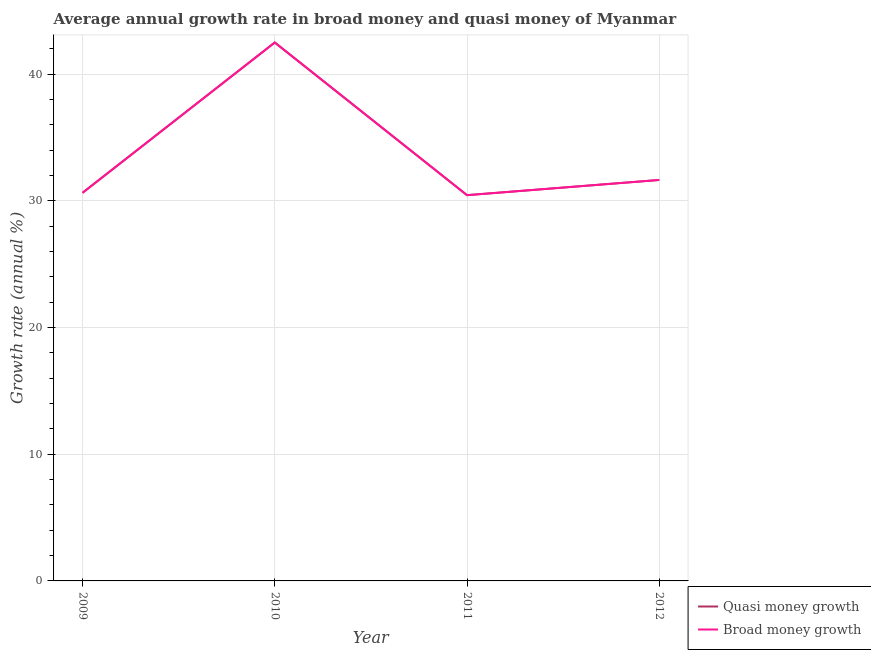Does the line corresponding to annual growth rate in quasi money intersect with the line corresponding to annual growth rate in broad money?
Make the answer very short. Yes. What is the annual growth rate in quasi money in 2009?
Provide a short and direct response. 30.64. Across all years, what is the maximum annual growth rate in broad money?
Ensure brevity in your answer.  42.5. Across all years, what is the minimum annual growth rate in quasi money?
Offer a terse response. 30.45. In which year was the annual growth rate in broad money minimum?
Make the answer very short. 2011. What is the total annual growth rate in broad money in the graph?
Provide a short and direct response. 135.24. What is the difference between the annual growth rate in quasi money in 2010 and that in 2012?
Provide a short and direct response. 10.85. What is the difference between the annual growth rate in quasi money in 2010 and the annual growth rate in broad money in 2011?
Provide a succinct answer. 12.05. What is the average annual growth rate in broad money per year?
Ensure brevity in your answer.  33.81. In how many years, is the annual growth rate in broad money greater than 4 %?
Make the answer very short. 4. What is the ratio of the annual growth rate in broad money in 2009 to that in 2012?
Make the answer very short. 0.97. Is the annual growth rate in broad money in 2010 less than that in 2012?
Provide a short and direct response. No. What is the difference between the highest and the second highest annual growth rate in quasi money?
Your answer should be compact. 10.85. What is the difference between the highest and the lowest annual growth rate in quasi money?
Ensure brevity in your answer.  12.05. In how many years, is the annual growth rate in broad money greater than the average annual growth rate in broad money taken over all years?
Make the answer very short. 1. Does the annual growth rate in quasi money monotonically increase over the years?
Your response must be concise. No. What is the difference between two consecutive major ticks on the Y-axis?
Your answer should be compact. 10. Does the graph contain any zero values?
Provide a succinct answer. No. Where does the legend appear in the graph?
Give a very brief answer. Bottom right. How many legend labels are there?
Offer a terse response. 2. How are the legend labels stacked?
Provide a short and direct response. Vertical. What is the title of the graph?
Keep it short and to the point. Average annual growth rate in broad money and quasi money of Myanmar. What is the label or title of the X-axis?
Offer a terse response. Year. What is the label or title of the Y-axis?
Offer a very short reply. Growth rate (annual %). What is the Growth rate (annual %) of Quasi money growth in 2009?
Offer a terse response. 30.64. What is the Growth rate (annual %) in Broad money growth in 2009?
Your answer should be compact. 30.64. What is the Growth rate (annual %) of Quasi money growth in 2010?
Provide a short and direct response. 42.5. What is the Growth rate (annual %) in Broad money growth in 2010?
Offer a terse response. 42.5. What is the Growth rate (annual %) in Quasi money growth in 2011?
Provide a succinct answer. 30.45. What is the Growth rate (annual %) of Broad money growth in 2011?
Give a very brief answer. 30.45. What is the Growth rate (annual %) of Quasi money growth in 2012?
Keep it short and to the point. 31.65. What is the Growth rate (annual %) of Broad money growth in 2012?
Your answer should be compact. 31.65. Across all years, what is the maximum Growth rate (annual %) of Quasi money growth?
Give a very brief answer. 42.5. Across all years, what is the maximum Growth rate (annual %) of Broad money growth?
Provide a short and direct response. 42.5. Across all years, what is the minimum Growth rate (annual %) of Quasi money growth?
Provide a short and direct response. 30.45. Across all years, what is the minimum Growth rate (annual %) in Broad money growth?
Provide a short and direct response. 30.45. What is the total Growth rate (annual %) in Quasi money growth in the graph?
Provide a short and direct response. 135.24. What is the total Growth rate (annual %) in Broad money growth in the graph?
Your response must be concise. 135.24. What is the difference between the Growth rate (annual %) in Quasi money growth in 2009 and that in 2010?
Ensure brevity in your answer.  -11.86. What is the difference between the Growth rate (annual %) of Broad money growth in 2009 and that in 2010?
Your answer should be very brief. -11.86. What is the difference between the Growth rate (annual %) in Quasi money growth in 2009 and that in 2011?
Keep it short and to the point. 0.19. What is the difference between the Growth rate (annual %) in Broad money growth in 2009 and that in 2011?
Keep it short and to the point. 0.19. What is the difference between the Growth rate (annual %) in Quasi money growth in 2009 and that in 2012?
Your answer should be compact. -1.01. What is the difference between the Growth rate (annual %) of Broad money growth in 2009 and that in 2012?
Offer a very short reply. -1.01. What is the difference between the Growth rate (annual %) of Quasi money growth in 2010 and that in 2011?
Your answer should be very brief. 12.05. What is the difference between the Growth rate (annual %) of Broad money growth in 2010 and that in 2011?
Provide a short and direct response. 12.05. What is the difference between the Growth rate (annual %) in Quasi money growth in 2010 and that in 2012?
Offer a terse response. 10.85. What is the difference between the Growth rate (annual %) in Broad money growth in 2010 and that in 2012?
Offer a terse response. 10.85. What is the difference between the Growth rate (annual %) of Quasi money growth in 2011 and that in 2012?
Provide a succinct answer. -1.2. What is the difference between the Growth rate (annual %) in Broad money growth in 2011 and that in 2012?
Keep it short and to the point. -1.2. What is the difference between the Growth rate (annual %) in Quasi money growth in 2009 and the Growth rate (annual %) in Broad money growth in 2010?
Keep it short and to the point. -11.86. What is the difference between the Growth rate (annual %) in Quasi money growth in 2009 and the Growth rate (annual %) in Broad money growth in 2011?
Your response must be concise. 0.19. What is the difference between the Growth rate (annual %) of Quasi money growth in 2009 and the Growth rate (annual %) of Broad money growth in 2012?
Give a very brief answer. -1.01. What is the difference between the Growth rate (annual %) of Quasi money growth in 2010 and the Growth rate (annual %) of Broad money growth in 2011?
Offer a terse response. 12.05. What is the difference between the Growth rate (annual %) in Quasi money growth in 2010 and the Growth rate (annual %) in Broad money growth in 2012?
Offer a terse response. 10.85. What is the difference between the Growth rate (annual %) of Quasi money growth in 2011 and the Growth rate (annual %) of Broad money growth in 2012?
Make the answer very short. -1.2. What is the average Growth rate (annual %) in Quasi money growth per year?
Your answer should be compact. 33.81. What is the average Growth rate (annual %) in Broad money growth per year?
Keep it short and to the point. 33.81. In the year 2009, what is the difference between the Growth rate (annual %) in Quasi money growth and Growth rate (annual %) in Broad money growth?
Your response must be concise. 0. In the year 2010, what is the difference between the Growth rate (annual %) in Quasi money growth and Growth rate (annual %) in Broad money growth?
Your answer should be very brief. 0. What is the ratio of the Growth rate (annual %) in Quasi money growth in 2009 to that in 2010?
Your answer should be very brief. 0.72. What is the ratio of the Growth rate (annual %) of Broad money growth in 2009 to that in 2010?
Make the answer very short. 0.72. What is the ratio of the Growth rate (annual %) of Broad money growth in 2009 to that in 2011?
Make the answer very short. 1.01. What is the ratio of the Growth rate (annual %) in Quasi money growth in 2010 to that in 2011?
Your response must be concise. 1.4. What is the ratio of the Growth rate (annual %) in Broad money growth in 2010 to that in 2011?
Your answer should be compact. 1.4. What is the ratio of the Growth rate (annual %) of Quasi money growth in 2010 to that in 2012?
Make the answer very short. 1.34. What is the ratio of the Growth rate (annual %) in Broad money growth in 2010 to that in 2012?
Offer a terse response. 1.34. What is the ratio of the Growth rate (annual %) of Quasi money growth in 2011 to that in 2012?
Your answer should be compact. 0.96. What is the ratio of the Growth rate (annual %) of Broad money growth in 2011 to that in 2012?
Offer a very short reply. 0.96. What is the difference between the highest and the second highest Growth rate (annual %) in Quasi money growth?
Provide a short and direct response. 10.85. What is the difference between the highest and the second highest Growth rate (annual %) of Broad money growth?
Your answer should be very brief. 10.85. What is the difference between the highest and the lowest Growth rate (annual %) of Quasi money growth?
Ensure brevity in your answer.  12.05. What is the difference between the highest and the lowest Growth rate (annual %) in Broad money growth?
Provide a succinct answer. 12.05. 